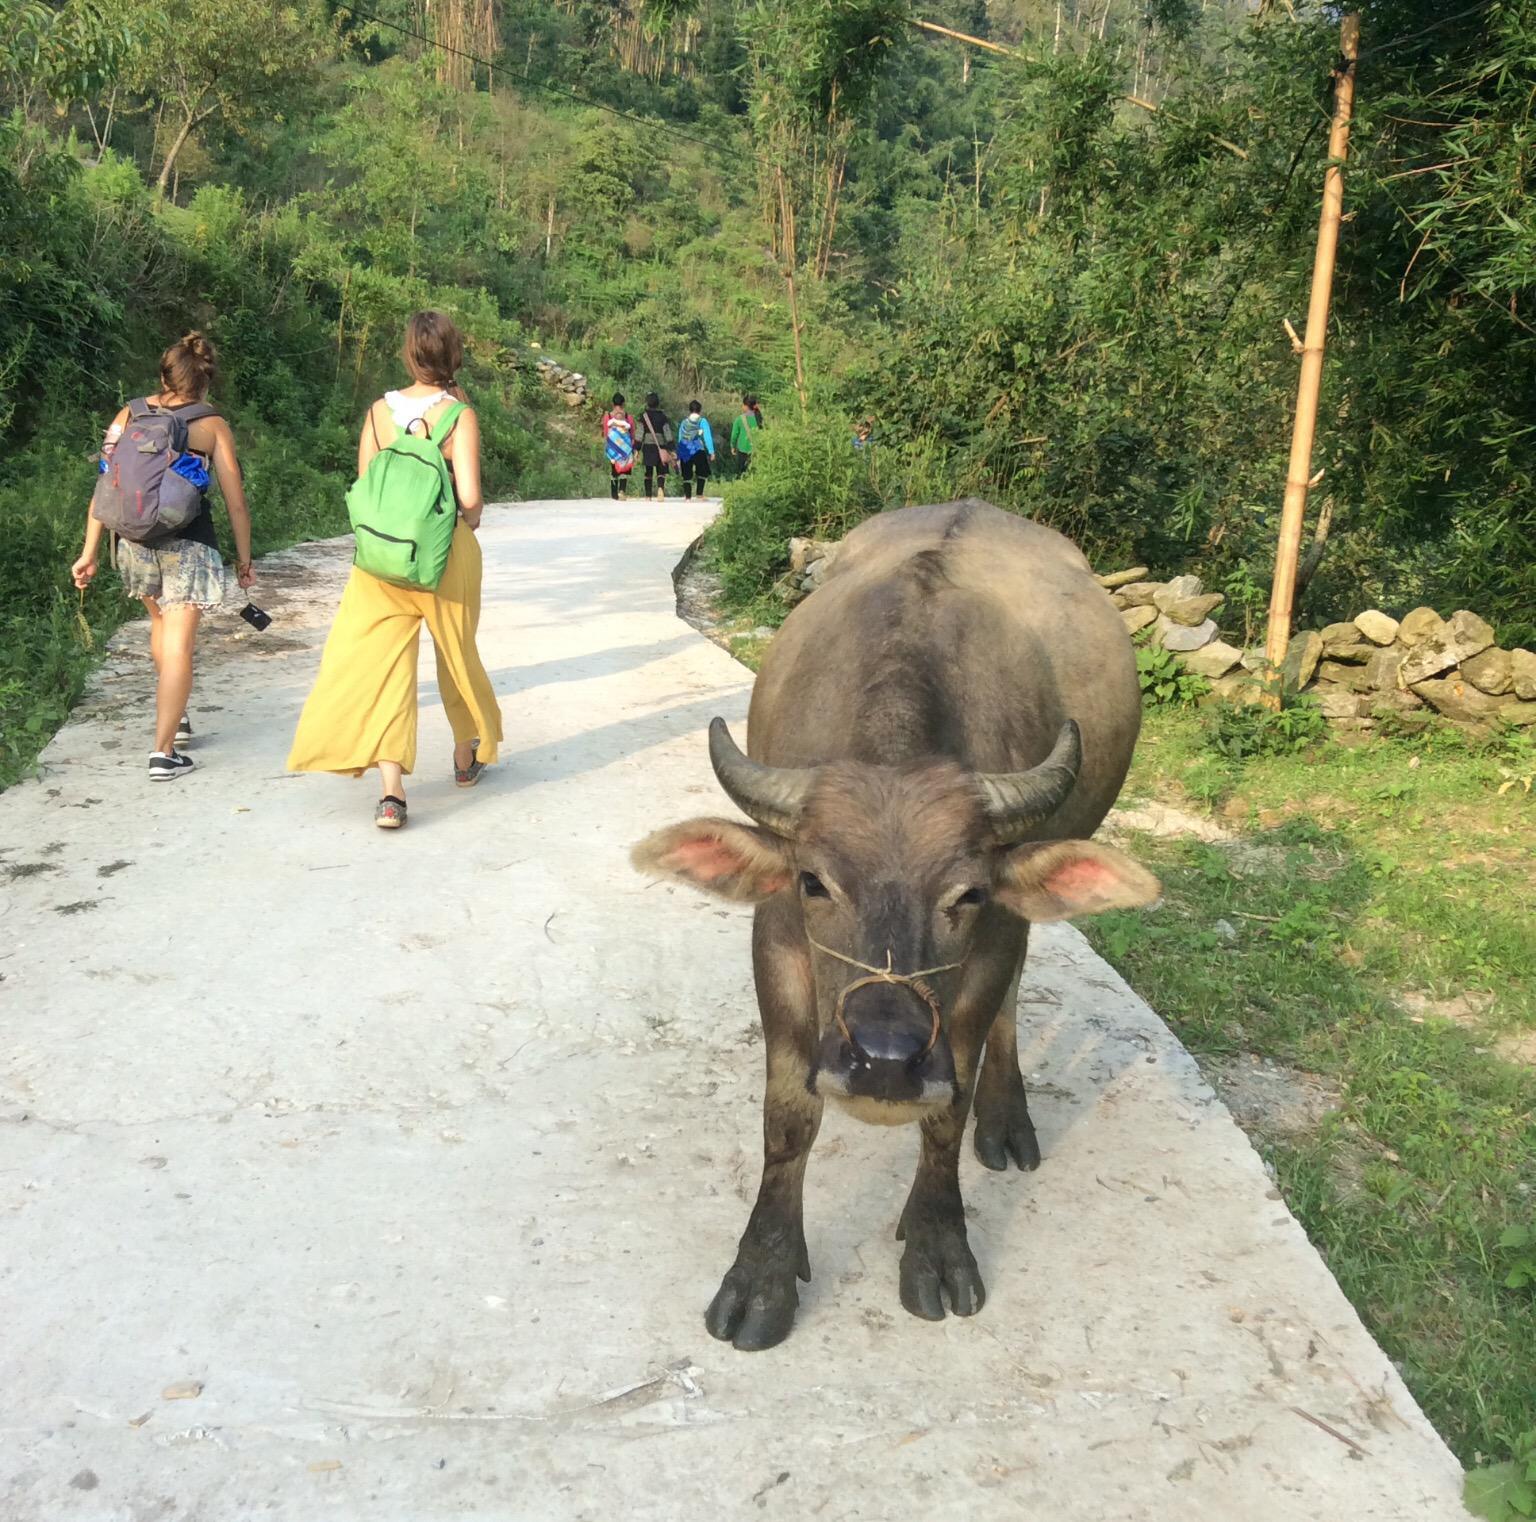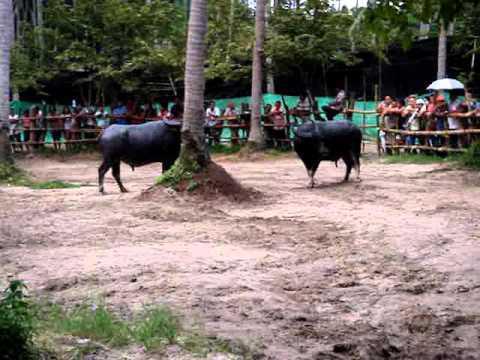The first image is the image on the left, the second image is the image on the right. For the images shown, is this caption "At least one person is behind a hitched team of two water buffalo in one image." true? Answer yes or no. No. The first image is the image on the left, the second image is the image on the right. For the images shown, is this caption "A water buffalo is being used to pull a person." true? Answer yes or no. No. 